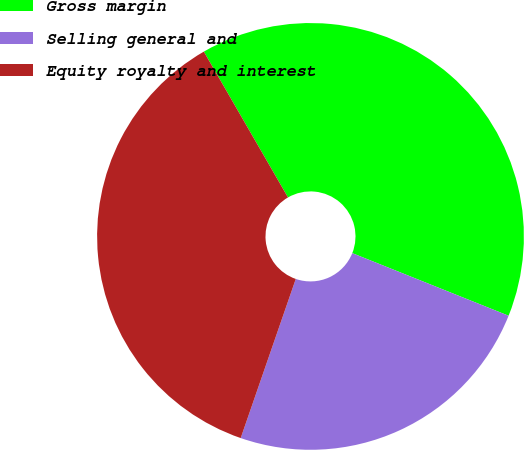Convert chart to OTSL. <chart><loc_0><loc_0><loc_500><loc_500><pie_chart><fcel>Gross margin<fcel>Selling general and<fcel>Equity royalty and interest<nl><fcel>39.39%<fcel>24.24%<fcel>36.36%<nl></chart> 